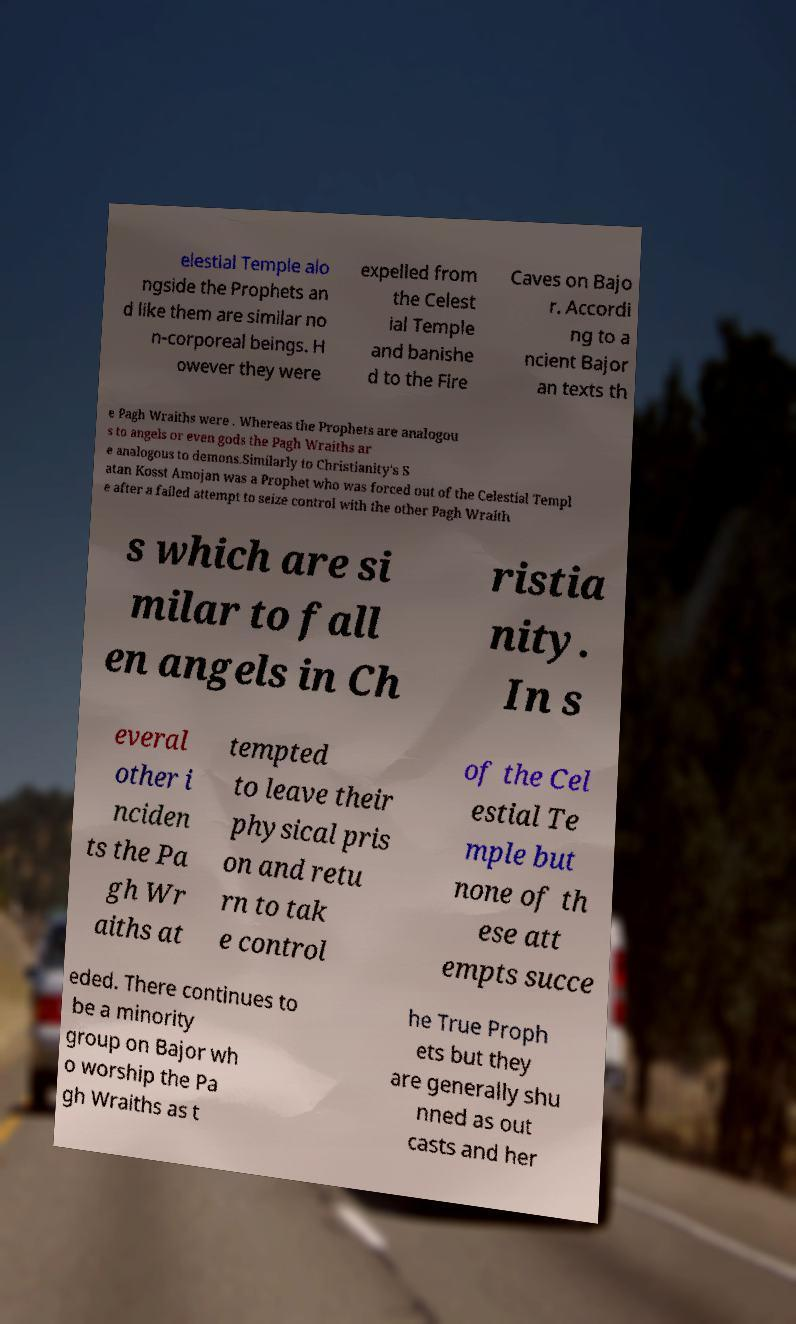Please read and relay the text visible in this image. What does it say? elestial Temple alo ngside the Prophets an d like them are similar no n-corporeal beings. H owever they were expelled from the Celest ial Temple and banishe d to the Fire Caves on Bajo r. Accordi ng to a ncient Bajor an texts th e Pagh Wraiths were . Whereas the Prophets are analogou s to angels or even gods the Pagh Wraiths ar e analogous to demons.Similarly to Christianity's S atan Kosst Amojan was a Prophet who was forced out of the Celestial Templ e after a failed attempt to seize control with the other Pagh Wraith s which are si milar to fall en angels in Ch ristia nity. In s everal other i nciden ts the Pa gh Wr aiths at tempted to leave their physical pris on and retu rn to tak e control of the Cel estial Te mple but none of th ese att empts succe eded. There continues to be a minority group on Bajor wh o worship the Pa gh Wraiths as t he True Proph ets but they are generally shu nned as out casts and her 